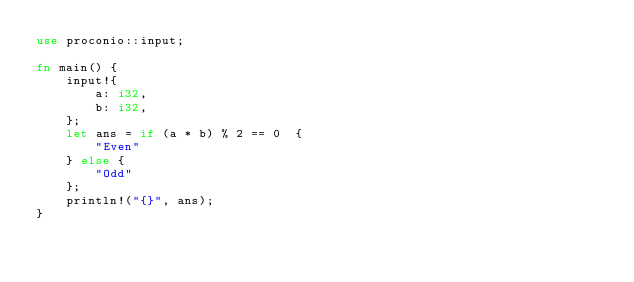<code> <loc_0><loc_0><loc_500><loc_500><_Rust_>use proconio::input;

fn main() {
    input!{
        a: i32,
        b: i32,
    };
    let ans = if (a * b) % 2 == 0  {
        "Even"
    } else {
        "Odd"
    };
    println!("{}", ans);
}
</code> 